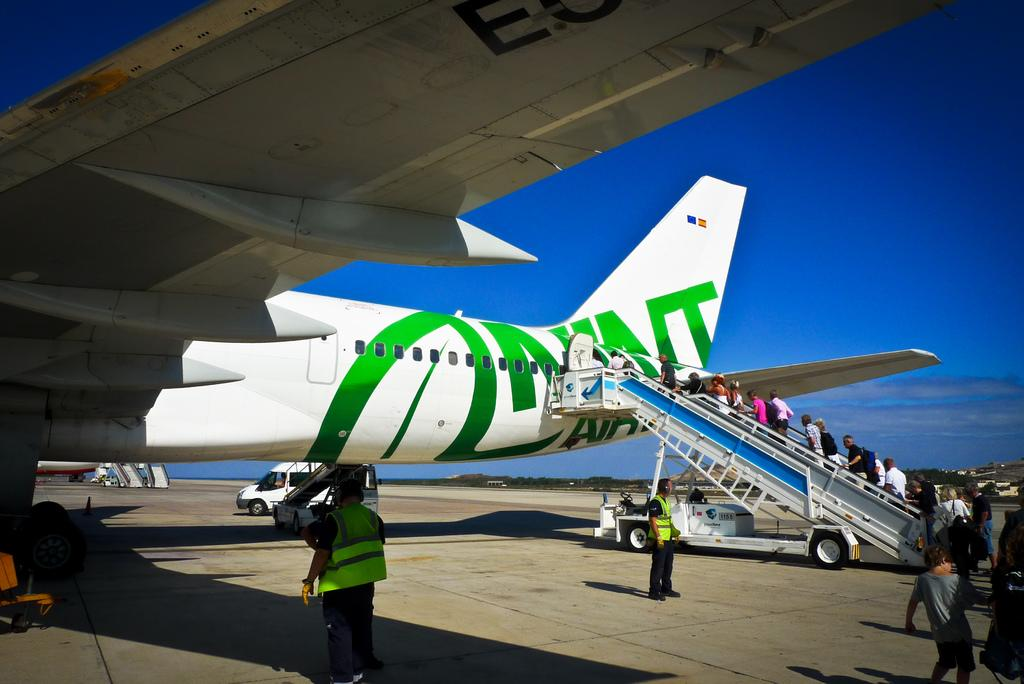Who or what can be seen in the image? There are people in the image. What type of transportation is present in the image? There is a plane in the image, and there are also vehicles on the road. What is the surface that the vehicles are traveling on? There is a road in the image. What can be seen in the background of the image? The sky is visible in the background of the image, and there are clouds in the sky. Where is the bedroom located in the image? There is no bedroom present in the image. What type of boot is being worn by the people in the image? There is no information about footwear in the image. 